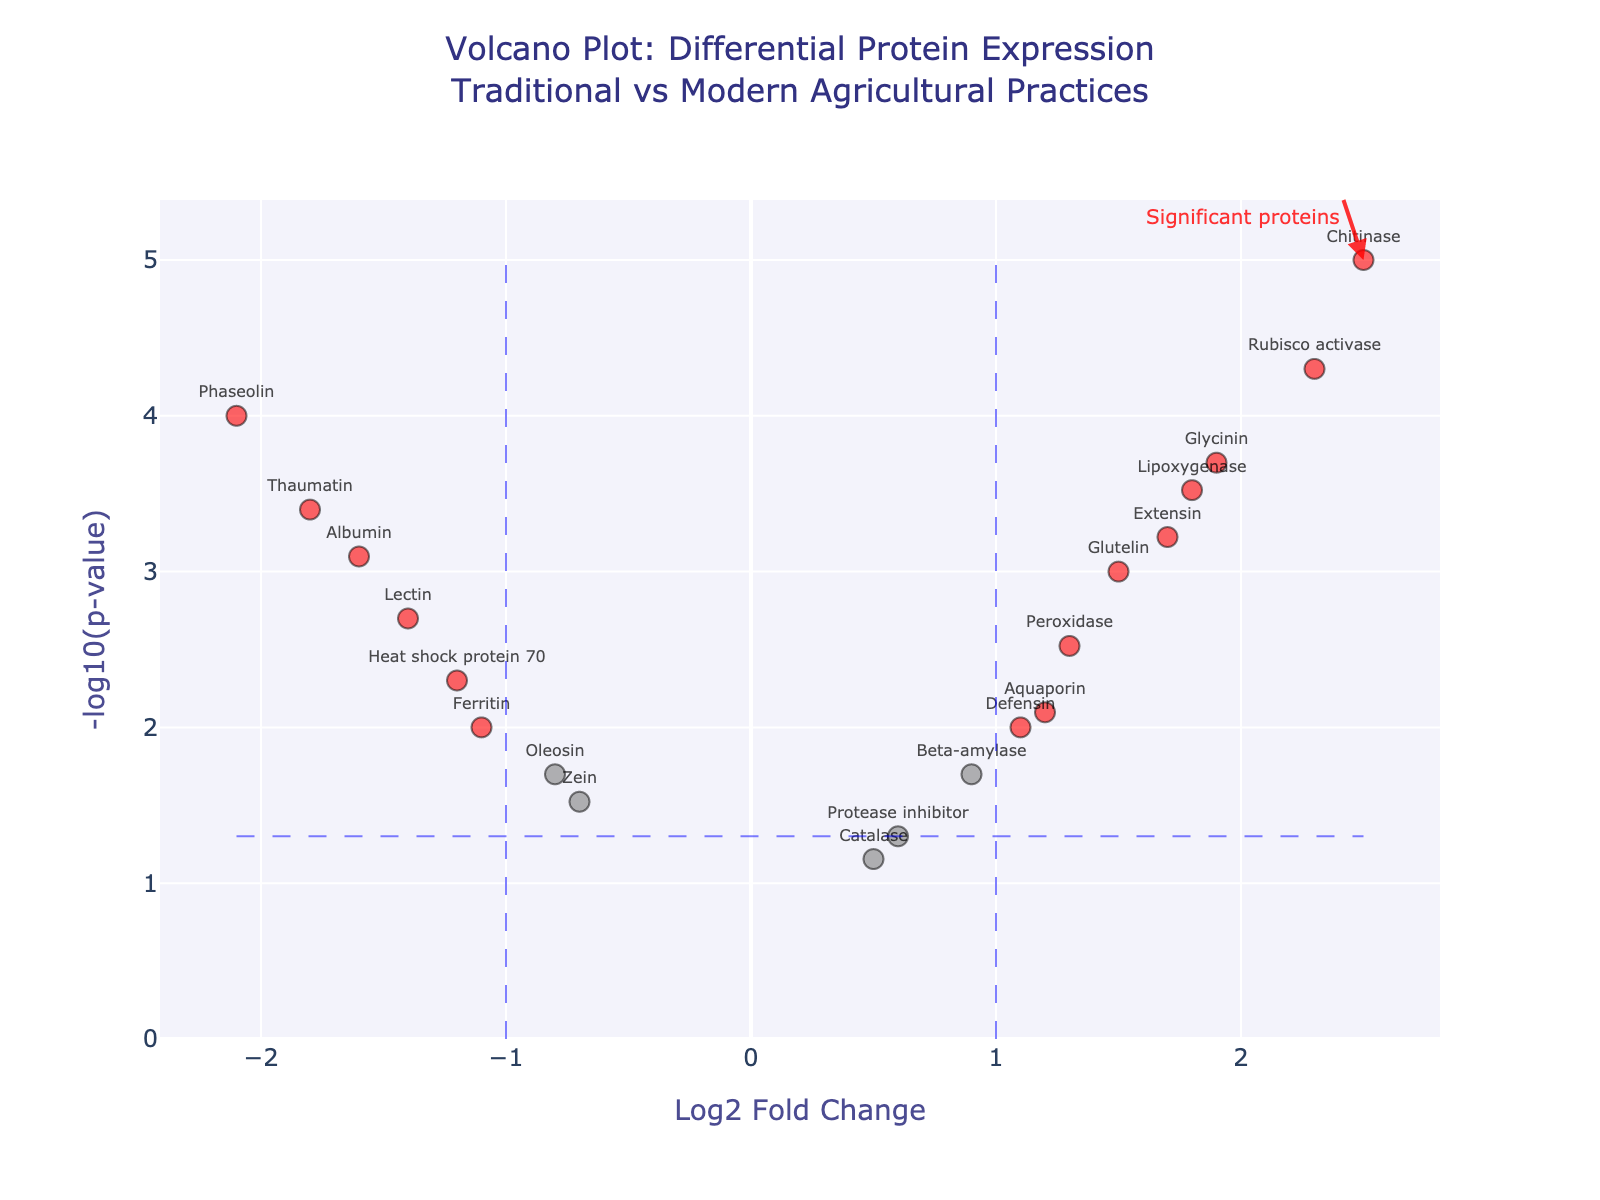What is the title of the figure? The title is clearly shown at the top of the figure. It says, "Volcano Plot: Differential Protein Expression Traditional vs Modern Agricultural Practices."
Answer: Volcano Plot: Differential Protein Expression Traditional vs Modern Agricultural Practices What do the axes represent? The x-axis represents the "Log2 Fold Change" and the y-axis represents the "-log10(p-value)" as described by their labels.
Answer: Log2 Fold Change (x-axis) and -log10(p-value) (y-axis) Which protein has the highest -log10(p-value)? By looking at the y-axis, the highest -log10(p-value) corresponds to Chitinase, which has the maximum value along the y-axis.
Answer: Chitinase How many proteins are identified as significant? Significant proteins are marked in red. Counting these markers in the plot provides the answer.
Answer: 9 Which protein has the largest positive log2FoldChange? The x-axis value of log2FoldChange shows Rubisco activase has the highest positive value.
Answer: Rubisco activase Are there any proteins with a log2FoldChange close to zero but highly significant (low p-value)? Protease inhibitor has a log2FoldChange close to zero (0.6) with a p-value < 0.05. Also, look for points near the center along the x-axis with a significant y-axis height.
Answer: Protease inhibitor Which protein has the lowest log2FoldChange and what is its p-value? Look at the left-most point on the x-axis. Phaseolin has the lowest log2FoldChange (-2.1) with a p-value of 0.0001.
Answer: Phaseolin, 0.0001 How is Rubisco activase differentially expressed in modern vs traditional agriculture practices? Rubisco activase has a log2FoldChange of 2.3, meaning it is upregulated in modern practices. Its p-value of 0.00005 indicates high significance.
Answer: Upregulated, log2FC 2.3, highly significant with p-value 0.00005 What can you infer about the traditional agricultural practices based on the albumin protein? Albumin has a log2FoldChange of -1.6 and a p-value of 0.0008, meaning it is downregulated in traditional practices with a high level of significance.
Answer: Downregulated, log2FC -1.6, p-value 0.0008 